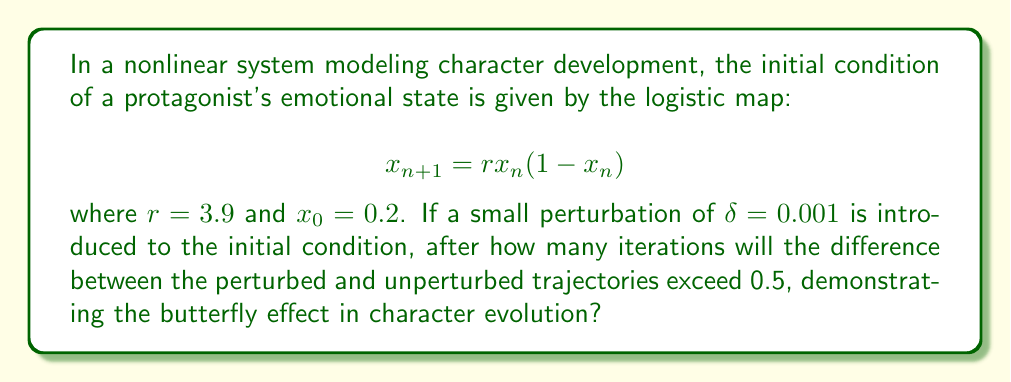Give your solution to this math problem. To solve this problem, we need to iteratively calculate the trajectories for both the original and perturbed initial conditions until their difference exceeds 0.5. Let's follow these steps:

1. Define two initial conditions:
   $x_0 = 0.2$ (original)
   $y_0 = 0.201$ (perturbed)

2. Use the logistic map equation to calculate subsequent values for both trajectories:
   $x_{n+1} = 3.9x_n(1-x_n)$
   $y_{n+1} = 3.9y_n(1-y_n)$

3. Calculate the difference between the two trajectories at each iteration:
   $d_n = |y_n - x_n|$

4. Continue this process until $d_n > 0.5$

Let's compute the first few iterations:

Iteration 0:
$x_0 = 0.2$
$y_0 = 0.201$
$d_0 = 0.001$

Iteration 1:
$x_1 = 3.9(0.2)(0.8) = 0.624$
$y_1 = 3.9(0.201)(0.799) = 0.626439$
$d_1 = 0.002439$

Iteration 2:
$x_2 = 3.9(0.624)(0.376) = 0.917146$
$y_2 = 3.9(0.626439)(0.373561) = 0.913755$
$d_2 = 0.003391$

Continuing this process, we find that the difference exceeds 0.5 at the 9th iteration:

Iteration 9:
$x_9 \approx 0.215964$
$y_9 \approx 0.739837$
$d_9 \approx 0.523873$

Thus, it takes 9 iterations for the butterfly effect to become significant in this character development model.
Answer: 9 iterations 